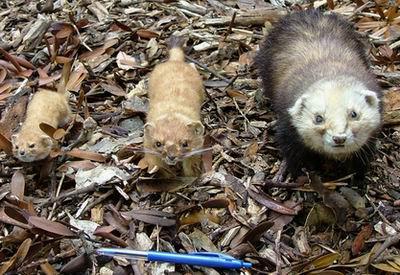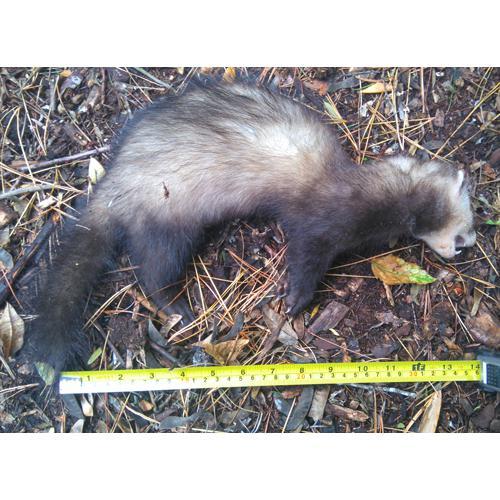The first image is the image on the left, the second image is the image on the right. Considering the images on both sides, is "An image shows a row of exactly three ferret-like animals of different sizes." valid? Answer yes or no. Yes. The first image is the image on the left, the second image is the image on the right. For the images shown, is this caption "Three animals are stretched out of the leaves in one of the images." true? Answer yes or no. Yes. 